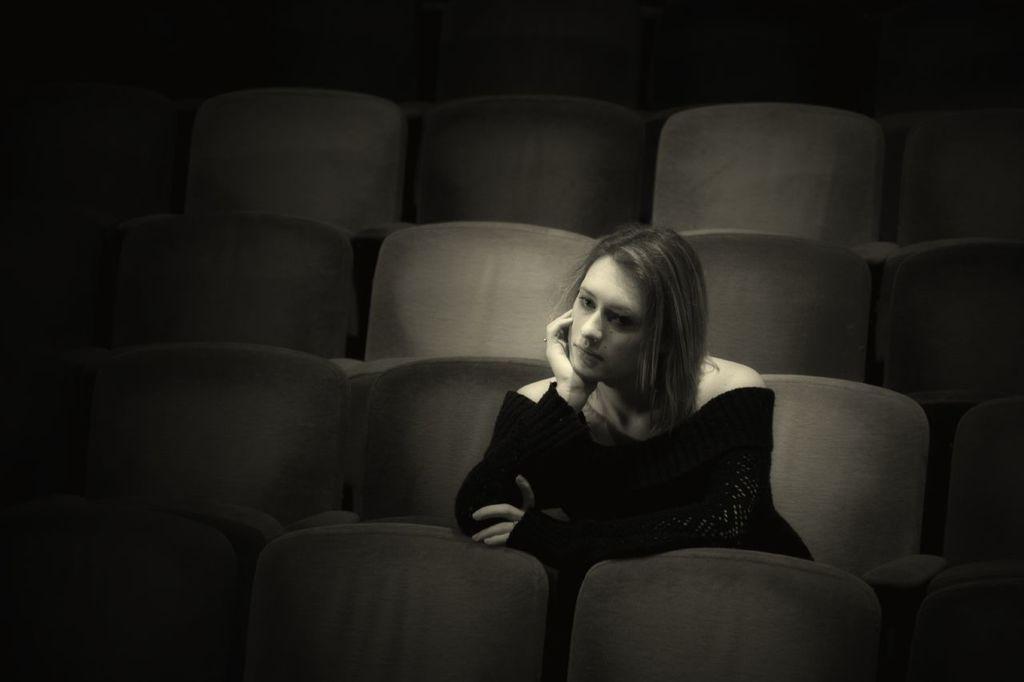In one or two sentences, can you explain what this image depicts? In this image, there is a woman sitting on the chair, looking sad and wearing black color top. In the background, chairs are visible. It looks as if the image is taken inside an auditorium or theater. 